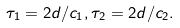<formula> <loc_0><loc_0><loc_500><loc_500>\tau _ { 1 } = 2 d / c _ { 1 } , \tau _ { 2 } = 2 d / c _ { 2 } .</formula> 